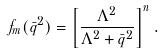Convert formula to latex. <formula><loc_0><loc_0><loc_500><loc_500>f _ { m } ( { \bar { q } ^ { 2 } } ) = \left [ \frac { \Lambda ^ { 2 } } { \Lambda ^ { 2 } + { \bar { q } ^ { 2 } } } \right ] ^ { n } .</formula> 